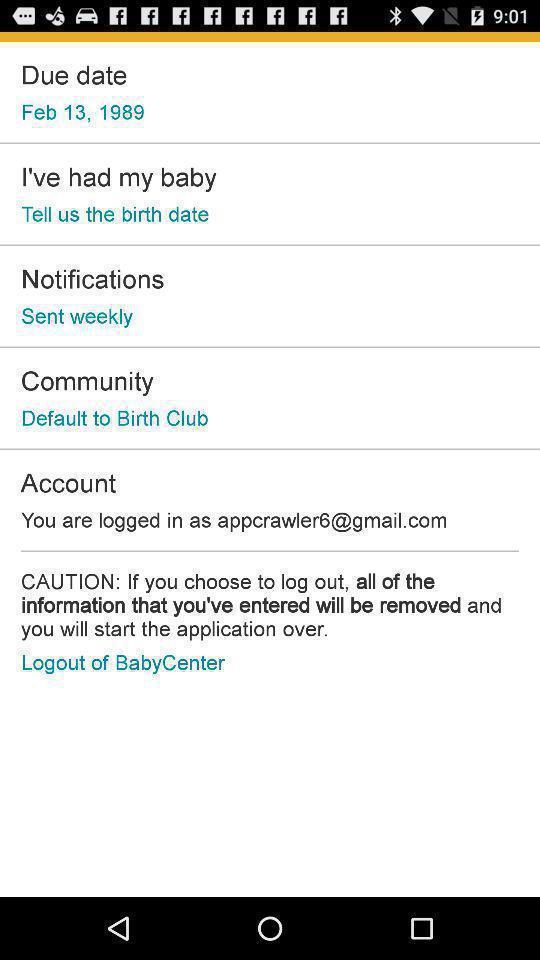Explain the elements present in this screenshot. Screen shows multiple options. 